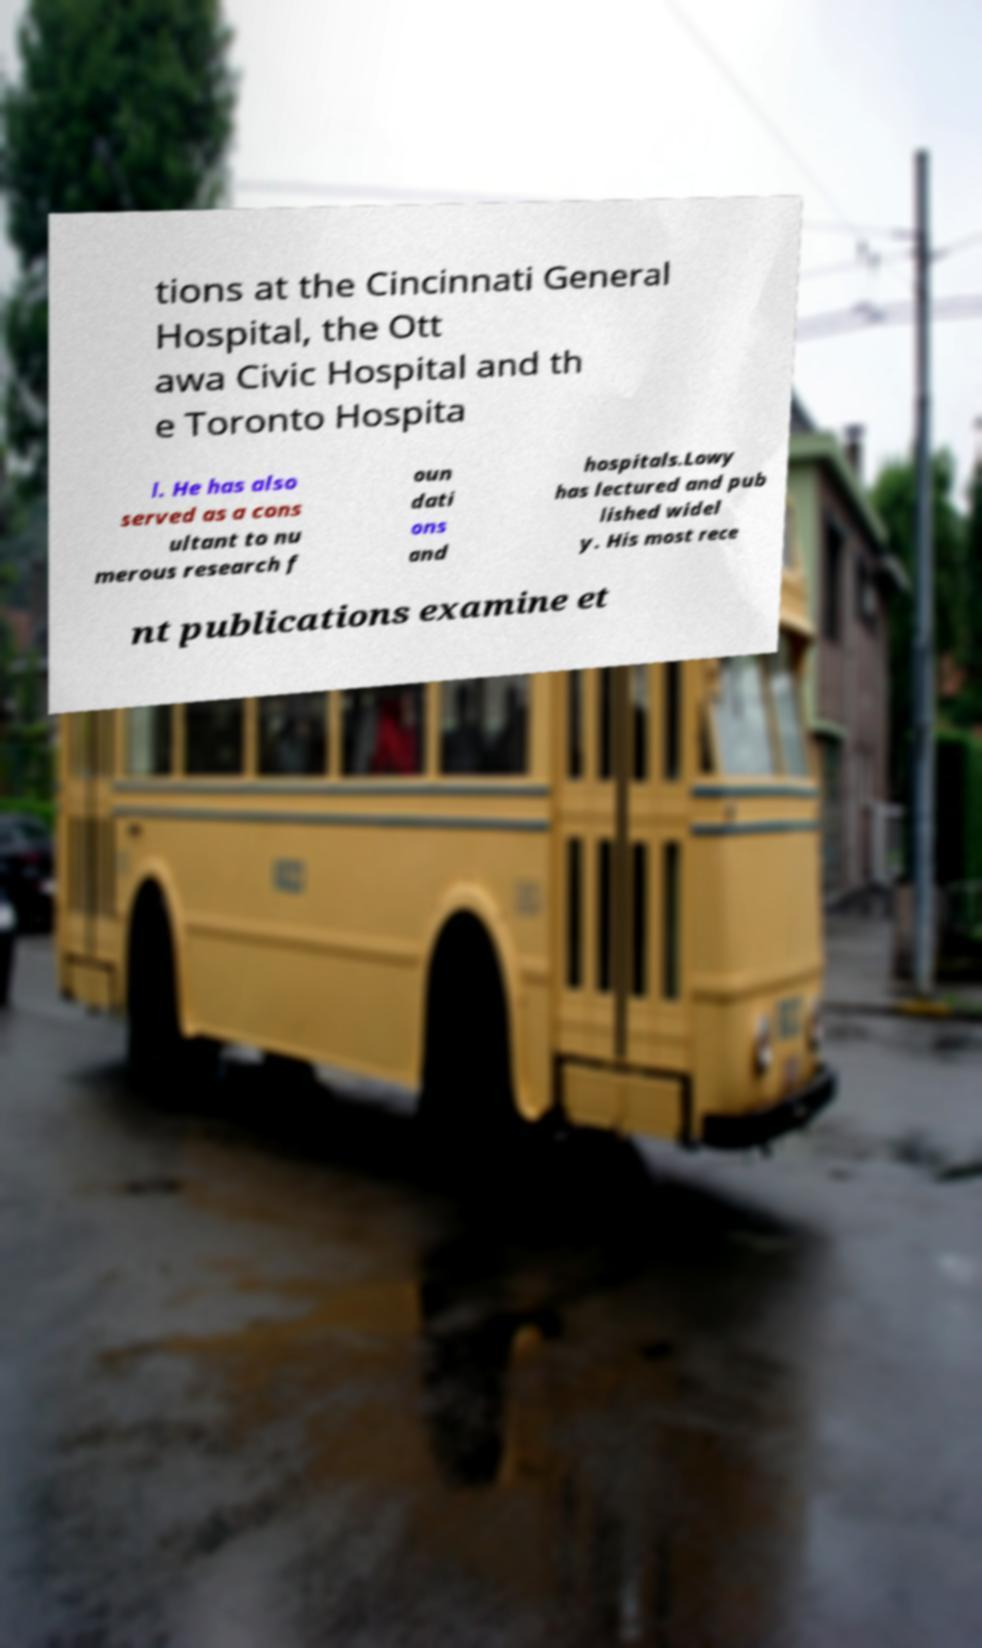What messages or text are displayed in this image? I need them in a readable, typed format. tions at the Cincinnati General Hospital, the Ott awa Civic Hospital and th e Toronto Hospita l. He has also served as a cons ultant to nu merous research f oun dati ons and hospitals.Lowy has lectured and pub lished widel y. His most rece nt publications examine et 